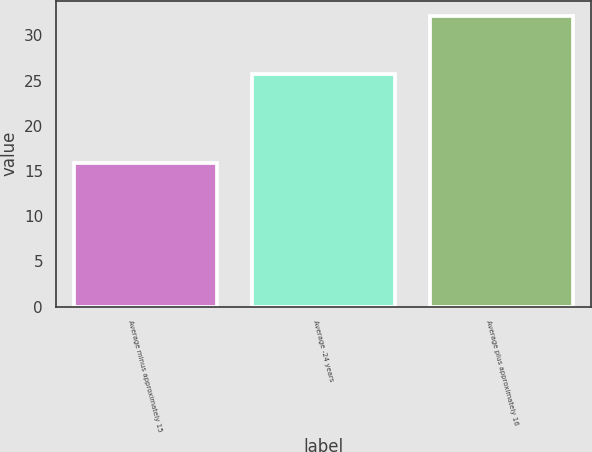Convert chart to OTSL. <chart><loc_0><loc_0><loc_500><loc_500><bar_chart><fcel>Average minus approximately 15<fcel>Average -24 years<fcel>Average plus approximately 16<nl><fcel>15.9<fcel>25.7<fcel>32.2<nl></chart> 